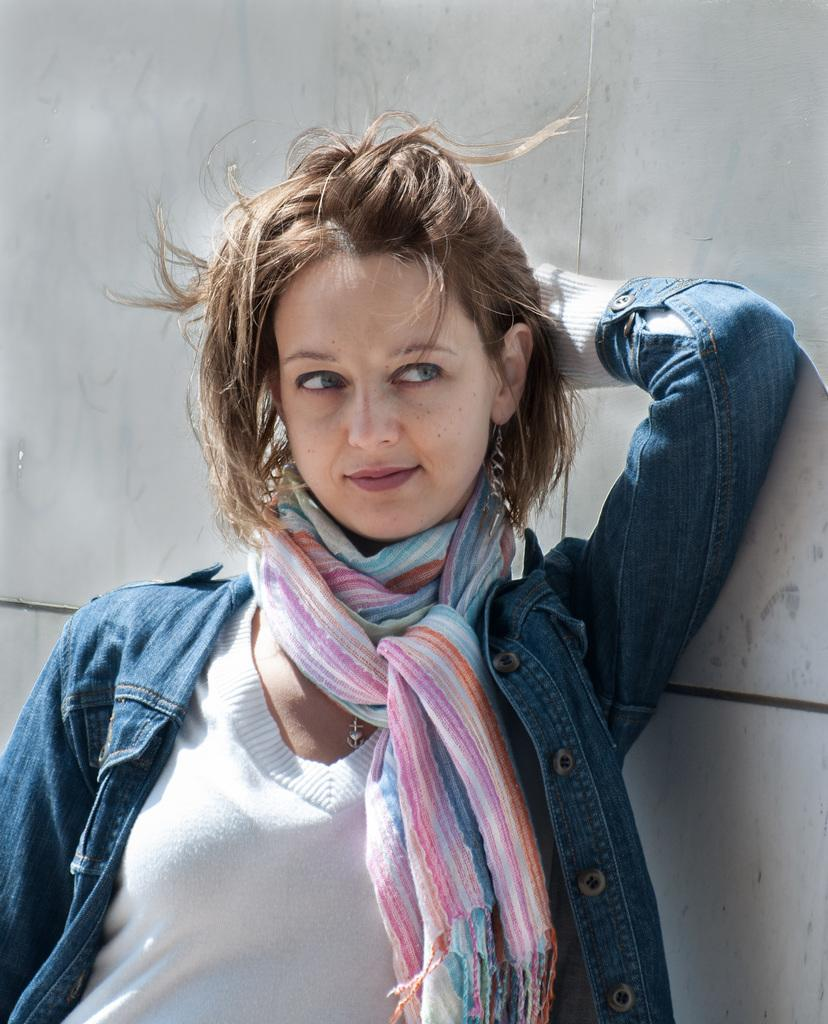Who is the main subject in the image? There is a woman in the image. What type of clothing is the woman wearing? The woman is wearing a denim jacket and a scarf. What can be seen behind the woman in the image? There is a wall behind the woman. What type of harmony does the woman's son play in the image? There is no mention of a son or any musical instruments in the image, so it is not possible to answer that question. 